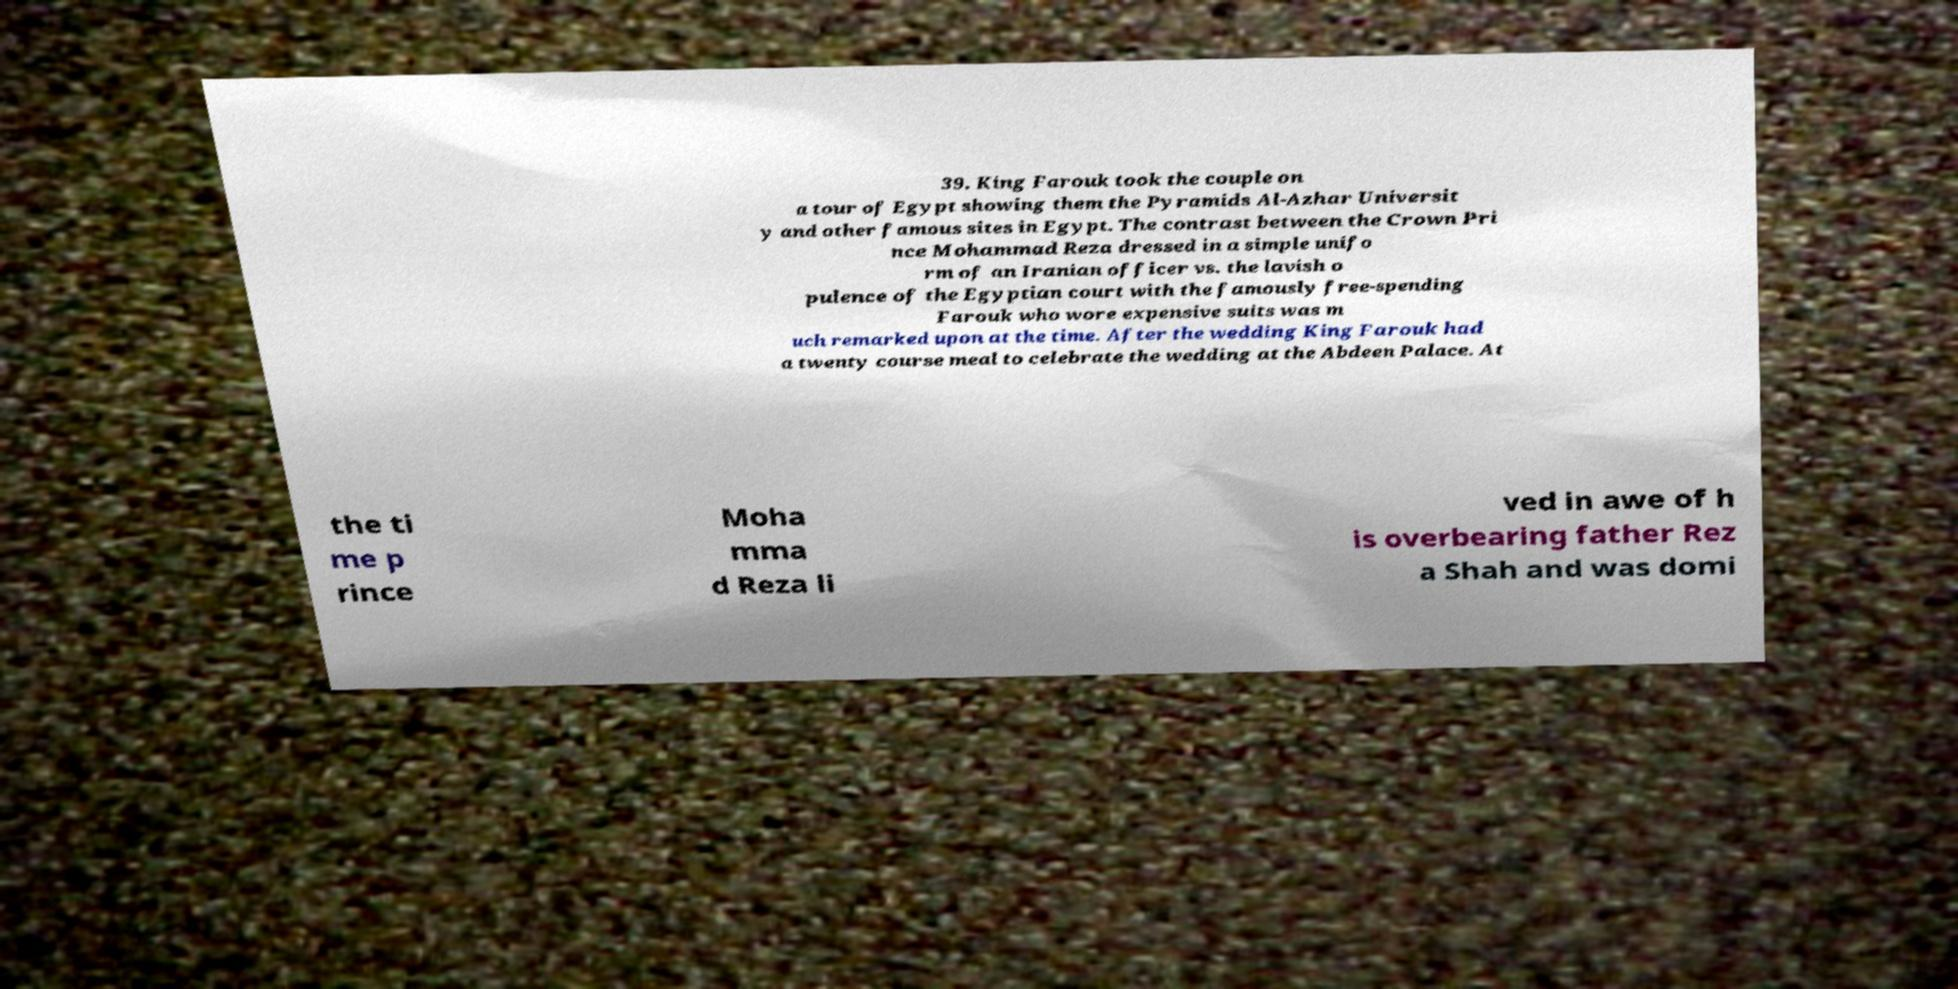Can you accurately transcribe the text from the provided image for me? 39. King Farouk took the couple on a tour of Egypt showing them the Pyramids Al-Azhar Universit y and other famous sites in Egypt. The contrast between the Crown Pri nce Mohammad Reza dressed in a simple unifo rm of an Iranian officer vs. the lavish o pulence of the Egyptian court with the famously free-spending Farouk who wore expensive suits was m uch remarked upon at the time. After the wedding King Farouk had a twenty course meal to celebrate the wedding at the Abdeen Palace. At the ti me p rince Moha mma d Reza li ved in awe of h is overbearing father Rez a Shah and was domi 